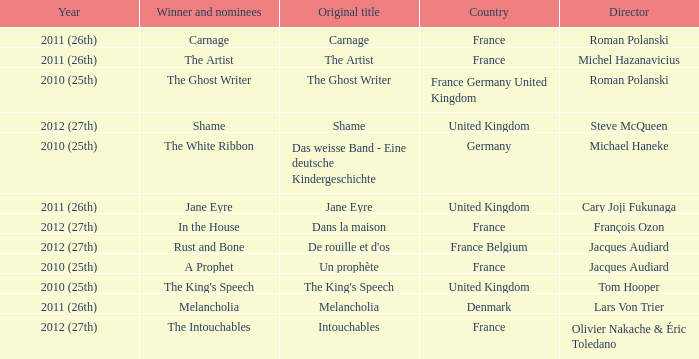What was the original title for the king's speech? The King's Speech. 